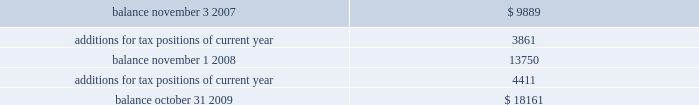Included in other non-current liabilities , because the company believes that the ultimate payment or settlement of these liabilities will not occur within the next twelve months .
Prior to the adoption of these provisions , these amounts were included in current income tax payable .
The company includes interest and penalties related to unrecognized tax benefits within the provision for taxes in the condensed consolidated statements of income , and as a result , no change in classification was made upon adopting these provisions .
The condensed consolidated statements of income for fiscal year 2009 and fiscal year 2008 include $ 1.7 million and $ 1.3 million , respectively , of interest and penalties related to these uncertain tax positions .
Due to the complexity associated with its tax uncertainties , the company cannot make a reasonably reliable estimate as to the period in which it expects to settle the liabilities associated with these uncertain tax positions .
The table summarizes the changes in the total amounts of uncertain tax positions for fiscal 2008 and fiscal 2009. .
Fiscal year 2004 and 2005 irs examination during the fourth quarter of fiscal 2007 , the irs completed its field examination of the company 2019s fiscal years 2004 and 2005 .
On january 2 , 2008 , the irs issued its report for fiscal 2004 and 2005 , which included proposed adjustments related to these two fiscal years .
The company has recorded taxes and penalties related to certain of these proposed adjustments .
There are four items with an additional potential total tax liability of $ 46 million .
The company has concluded , based on discussions with its tax advisors , that these four items are not likely to result in any additional tax liability .
Therefore , the company has not recorded any additional tax liability for these items and is appealing these proposed adjustments through the normal processes for the resolution of differences between the irs and taxpayers .
The company 2019s initial meetings with the appellate division of the irs were held during fiscal year 2009 .
Two of the unresolved matters are one-time issues and pertain to section 965 of the internal revenue code related to the beneficial tax treatment of dividends from foreign owned companies under the american jobs creation act .
The other matters pertain to the computation of research and development ( r&d ) tax credits and the profits earned from manufacturing activities carried on outside the united states .
These latter two matters could impact taxes payable for fiscal 2004 and 2005 as well as for subsequent years .
Fiscal year 2006 and 2007 irs examination during the third quarter of fiscal 2009 , the irs completed its field examination of the company 2019s fiscal years 2006 and 2007 .
The irs and the company have agreed on the treatment of a number of issues that have been included in an issue resolutions agreement related to the 2006 and 2007 tax returns .
However , no agreement was reached on the tax treatment of a number of issues , including the same r&d credit and foreign manufacturing issues mentioned above related to fiscal 2004 and 2005 , the pricing of intercompany sales ( transfer pricing ) , and the deductibility of certain stock option compensation expenses .
During the third quarter of fiscal 2009 , the irs issued its report for fiscal 2006 and fiscal 2007 , which included proposed adjustments related to these two fiscal years .
The company has recorded taxes and penalties related to certain of these proposed adjustments .
There are four items with an additional potential total tax liability of $ 195 million .
The company concluded , based on discussions with its tax advisors , that these four items are not likely to result in any additional tax liability .
Therefore , the company has not recorded any additional tax liability for these items and is appealing these proposed adjustments through the normal processes for the resolution of differences between the irs and taxpayers .
With the exception of the analog devices , inc .
Notes to consolidated financial statements 2014 ( continued ) .
What is the net change in the balance of total amounts of uncertain tax positions from 2007 to 2009? 
Computations: (18161 - 9889)
Answer: 8272.0. Included in other non-current liabilities , because the company believes that the ultimate payment or settlement of these liabilities will not occur within the next twelve months .
Prior to the adoption of these provisions , these amounts were included in current income tax payable .
The company includes interest and penalties related to unrecognized tax benefits within the provision for taxes in the condensed consolidated statements of income , and as a result , no change in classification was made upon adopting these provisions .
The condensed consolidated statements of income for fiscal year 2009 and fiscal year 2008 include $ 1.7 million and $ 1.3 million , respectively , of interest and penalties related to these uncertain tax positions .
Due to the complexity associated with its tax uncertainties , the company cannot make a reasonably reliable estimate as to the period in which it expects to settle the liabilities associated with these uncertain tax positions .
The table summarizes the changes in the total amounts of uncertain tax positions for fiscal 2008 and fiscal 2009. .
Fiscal year 2004 and 2005 irs examination during the fourth quarter of fiscal 2007 , the irs completed its field examination of the company 2019s fiscal years 2004 and 2005 .
On january 2 , 2008 , the irs issued its report for fiscal 2004 and 2005 , which included proposed adjustments related to these two fiscal years .
The company has recorded taxes and penalties related to certain of these proposed adjustments .
There are four items with an additional potential total tax liability of $ 46 million .
The company has concluded , based on discussions with its tax advisors , that these four items are not likely to result in any additional tax liability .
Therefore , the company has not recorded any additional tax liability for these items and is appealing these proposed adjustments through the normal processes for the resolution of differences between the irs and taxpayers .
The company 2019s initial meetings with the appellate division of the irs were held during fiscal year 2009 .
Two of the unresolved matters are one-time issues and pertain to section 965 of the internal revenue code related to the beneficial tax treatment of dividends from foreign owned companies under the american jobs creation act .
The other matters pertain to the computation of research and development ( r&d ) tax credits and the profits earned from manufacturing activities carried on outside the united states .
These latter two matters could impact taxes payable for fiscal 2004 and 2005 as well as for subsequent years .
Fiscal year 2006 and 2007 irs examination during the third quarter of fiscal 2009 , the irs completed its field examination of the company 2019s fiscal years 2006 and 2007 .
The irs and the company have agreed on the treatment of a number of issues that have been included in an issue resolutions agreement related to the 2006 and 2007 tax returns .
However , no agreement was reached on the tax treatment of a number of issues , including the same r&d credit and foreign manufacturing issues mentioned above related to fiscal 2004 and 2005 , the pricing of intercompany sales ( transfer pricing ) , and the deductibility of certain stock option compensation expenses .
During the third quarter of fiscal 2009 , the irs issued its report for fiscal 2006 and fiscal 2007 , which included proposed adjustments related to these two fiscal years .
The company has recorded taxes and penalties related to certain of these proposed adjustments .
There are four items with an additional potential total tax liability of $ 195 million .
The company concluded , based on discussions with its tax advisors , that these four items are not likely to result in any additional tax liability .
Therefore , the company has not recorded any additional tax liability for these items and is appealing these proposed adjustments through the normal processes for the resolution of differences between the irs and taxpayers .
With the exception of the analog devices , inc .
Notes to consolidated financial statements 2014 ( continued ) .
What is the percentage increase in interest expanse and penalties in 2009? 
Computations: ((1.7 - 1.3) / 1.3)
Answer: 0.30769. Included in other non-current liabilities , because the company believes that the ultimate payment or settlement of these liabilities will not occur within the next twelve months .
Prior to the adoption of these provisions , these amounts were included in current income tax payable .
The company includes interest and penalties related to unrecognized tax benefits within the provision for taxes in the condensed consolidated statements of income , and as a result , no change in classification was made upon adopting these provisions .
The condensed consolidated statements of income for fiscal year 2009 and fiscal year 2008 include $ 1.7 million and $ 1.3 million , respectively , of interest and penalties related to these uncertain tax positions .
Due to the complexity associated with its tax uncertainties , the company cannot make a reasonably reliable estimate as to the period in which it expects to settle the liabilities associated with these uncertain tax positions .
The table summarizes the changes in the total amounts of uncertain tax positions for fiscal 2008 and fiscal 2009. .
Fiscal year 2004 and 2005 irs examination during the fourth quarter of fiscal 2007 , the irs completed its field examination of the company 2019s fiscal years 2004 and 2005 .
On january 2 , 2008 , the irs issued its report for fiscal 2004 and 2005 , which included proposed adjustments related to these two fiscal years .
The company has recorded taxes and penalties related to certain of these proposed adjustments .
There are four items with an additional potential total tax liability of $ 46 million .
The company has concluded , based on discussions with its tax advisors , that these four items are not likely to result in any additional tax liability .
Therefore , the company has not recorded any additional tax liability for these items and is appealing these proposed adjustments through the normal processes for the resolution of differences between the irs and taxpayers .
The company 2019s initial meetings with the appellate division of the irs were held during fiscal year 2009 .
Two of the unresolved matters are one-time issues and pertain to section 965 of the internal revenue code related to the beneficial tax treatment of dividends from foreign owned companies under the american jobs creation act .
The other matters pertain to the computation of research and development ( r&d ) tax credits and the profits earned from manufacturing activities carried on outside the united states .
These latter two matters could impact taxes payable for fiscal 2004 and 2005 as well as for subsequent years .
Fiscal year 2006 and 2007 irs examination during the third quarter of fiscal 2009 , the irs completed its field examination of the company 2019s fiscal years 2006 and 2007 .
The irs and the company have agreed on the treatment of a number of issues that have been included in an issue resolutions agreement related to the 2006 and 2007 tax returns .
However , no agreement was reached on the tax treatment of a number of issues , including the same r&d credit and foreign manufacturing issues mentioned above related to fiscal 2004 and 2005 , the pricing of intercompany sales ( transfer pricing ) , and the deductibility of certain stock option compensation expenses .
During the third quarter of fiscal 2009 , the irs issued its report for fiscal 2006 and fiscal 2007 , which included proposed adjustments related to these two fiscal years .
The company has recorded taxes and penalties related to certain of these proposed adjustments .
There are four items with an additional potential total tax liability of $ 195 million .
The company concluded , based on discussions with its tax advisors , that these four items are not likely to result in any additional tax liability .
Therefore , the company has not recorded any additional tax liability for these items and is appealing these proposed adjustments through the normal processes for the resolution of differences between the irs and taxpayers .
With the exception of the analog devices , inc .
Notes to consolidated financial statements 2014 ( continued ) .
What percentage did the balance increase from 2007 to 2009? 
Rationale: to find the percentage increase one must subtract the two year's balances and then divide the answer by the balance for 2007 .
Computations: ((18161 - 9889) / 9889)
Answer: 0.83648. 